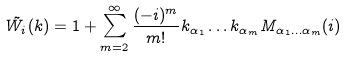Convert formula to latex. <formula><loc_0><loc_0><loc_500><loc_500>\tilde { W _ { i } } ( { k } ) = 1 + \sum _ { m = 2 } ^ { \infty } \frac { ( - i ) ^ { m } } { m ! } k _ { \alpha _ { 1 } } \dots k _ { \alpha _ { m } } M _ { \alpha _ { 1 } \dots \alpha _ { m } } ( i )</formula> 